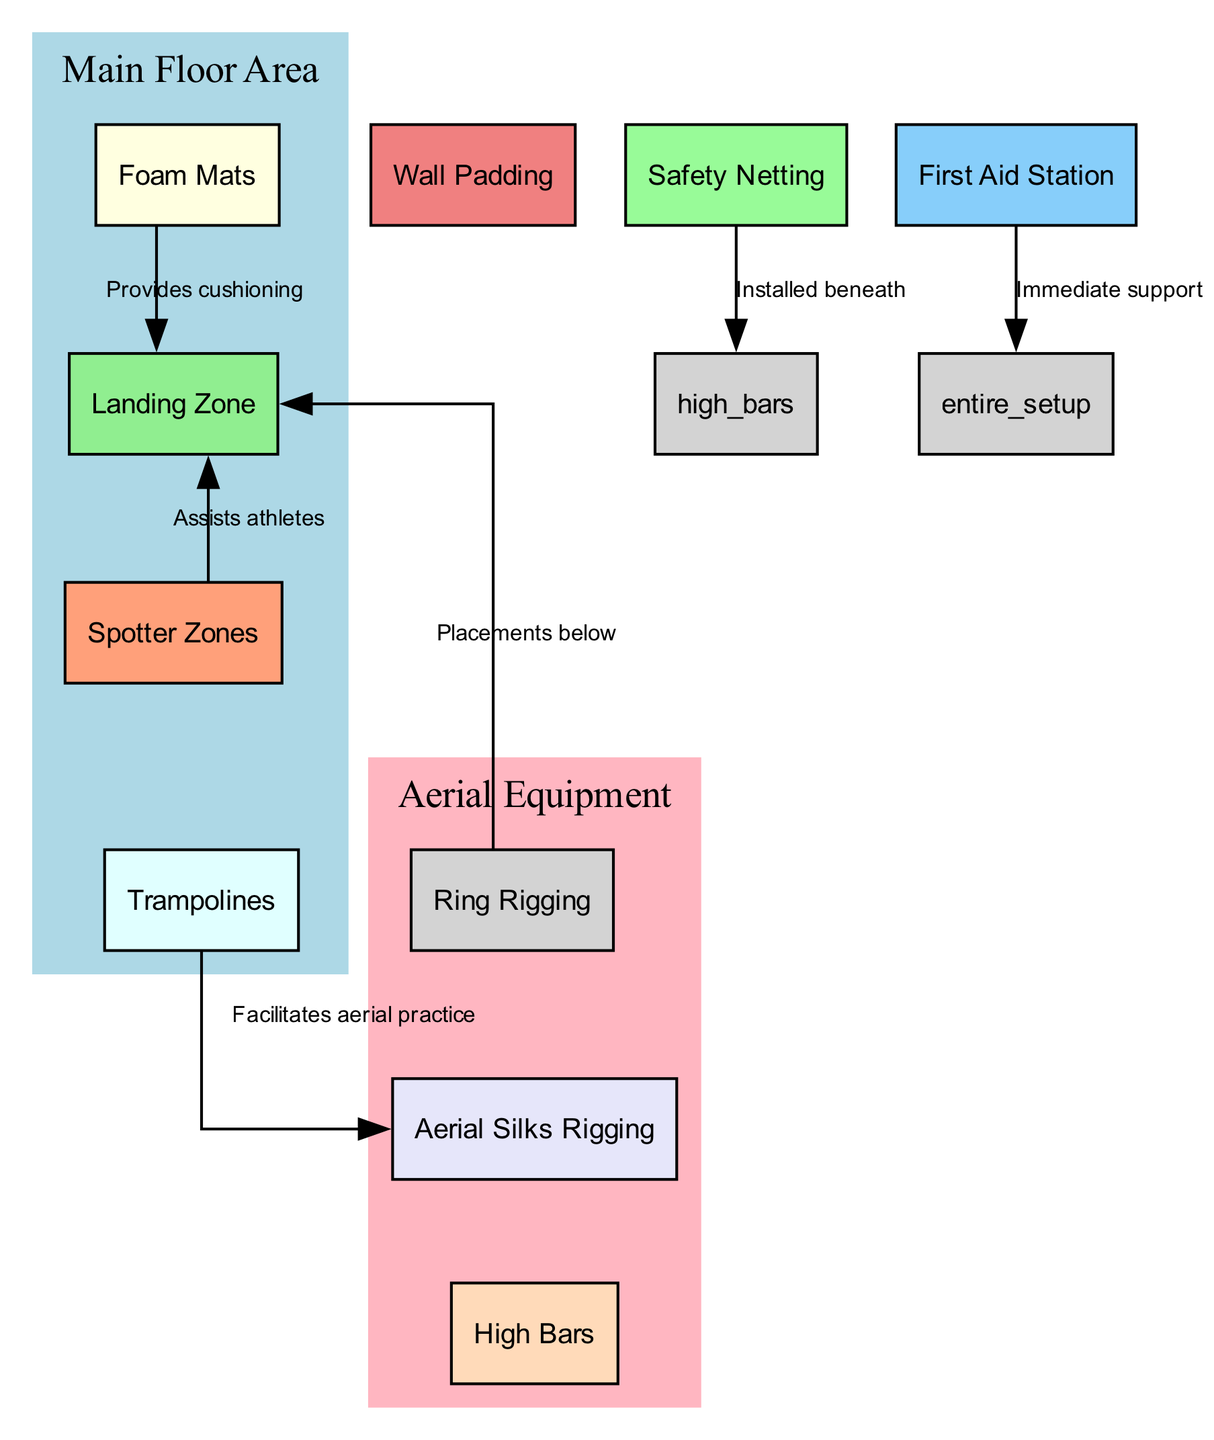What is the purpose of the landing zone? The landing zone is specifically designed to provide extra cushioning for athletes when they land, ensuring a safer practice environment. This is confirmed by the description associated with the node labeled "Landing Zone."
Answer: Extra thick mats placed below aerial apparatus for safe landing How many main floor areas are depicted in the diagram? The diagram shows one main floor area that includes nodes for "Foam Mats," "Landing Zone," "Spotter Zones," and "Trampolines," collectively indicating a single main floor area.
Answer: 1 What type of safety equipment is located beneath the high bars? The safety netting is specifically noted to be installed beneath the high bars to catch falls. This relationship is indicated by the edge connecting the "Safety Netting" and the "High Bars."
Answer: Safety Netting Which equipment assists athletes during their aerial routines? The spotter zones are designated areas for spotters to stand safely while assisting athletes, making them crucial for athlete safety during aerial activities. The diagram indicates this relationship directly.
Answer: Spotter Zones How does foam mats relate to the landing zone? The foam mats provide cushioning for the landing zone, acting as a foundational layer to soften impacts when athletes land. This relationship is illustrated by an edge connecting the two nodes.
Answer: Provides cushioning What is the role of the first aid station in the gymnasium setup? The first aid station is equipped with medical supplies for immediate injury treatment, which is essential for ensuring athlete safety in case of an accident. The diagram explicitly states this purpose.
Answer: Immediate support How many types of rigging equipment are shown in the diagram? The diagram depicts two types of rigging equipment: "Ring Rigging" and "Aerial Silks Rigging." Counting these nodes confirms their presence and role in aerial activities.
Answer: 2 What is the relationship between the trampoline and silks rigging? The trampoline facilitates aerial practice, assisting with skills that may involve the silks rigging; this is indicated through the connection in the diagram.
Answer: Facilitates aerial practice What surrounds the entire setup for protective purposes? The wall padding surrounds the entire setup to cushion against accidental collisions, as indicated in the relationships present across the diagram.
Answer: Protective enclosure What equipment is directly above the landing area? The ring rigging is placed above the landing zone for aerial routines, and this placement is explicitly referenced in the diagram's connections.
Answer: Ring Rigging 